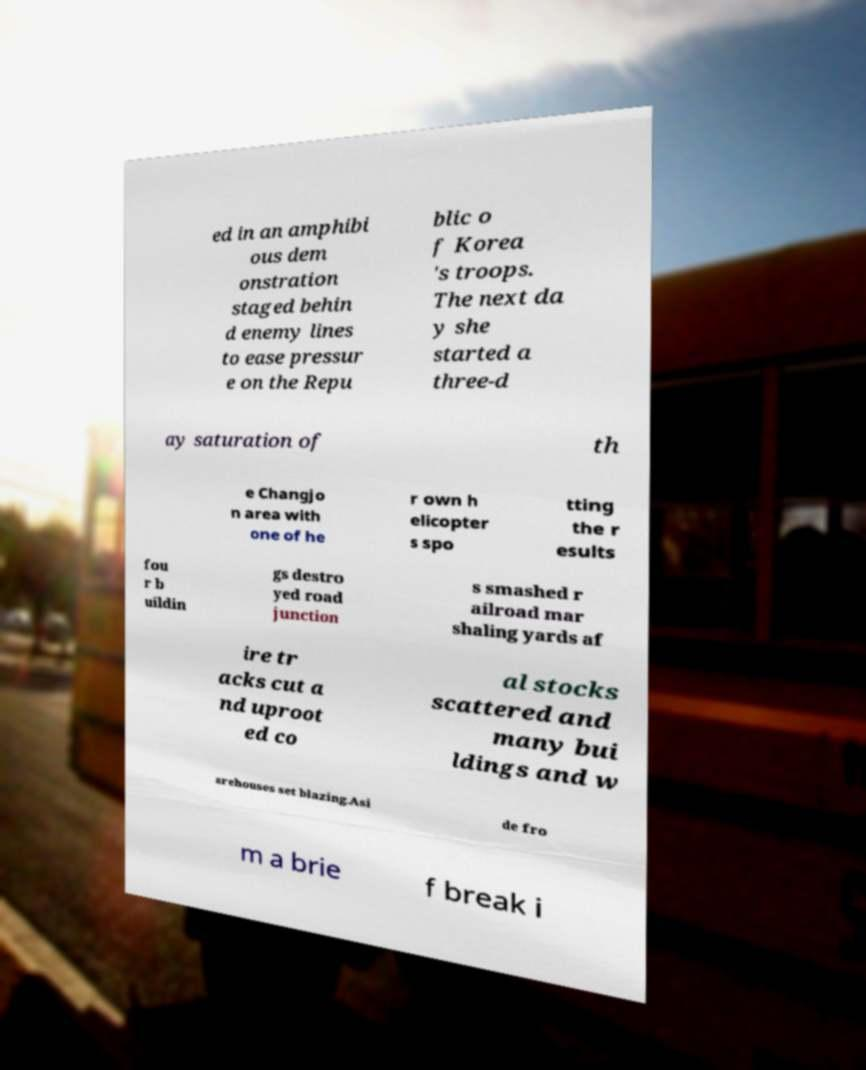There's text embedded in this image that I need extracted. Can you transcribe it verbatim? ed in an amphibi ous dem onstration staged behin d enemy lines to ease pressur e on the Repu blic o f Korea 's troops. The next da y she started a three-d ay saturation of th e Changjo n area with one of he r own h elicopter s spo tting the r esults fou r b uildin gs destro yed road junction s smashed r ailroad mar shaling yards af ire tr acks cut a nd uproot ed co al stocks scattered and many bui ldings and w arehouses set blazing.Asi de fro m a brie f break i 